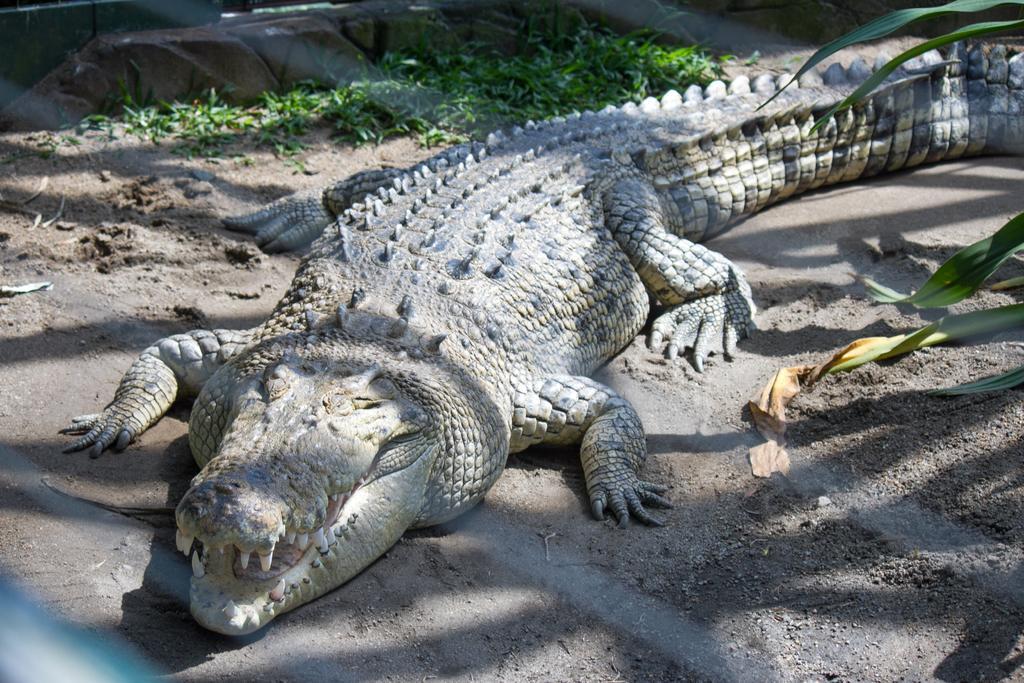In one or two sentences, can you explain what this image depicts? In this picture there is a crocodile, beside him i can see the grass. At the bottom there is a fencing. 